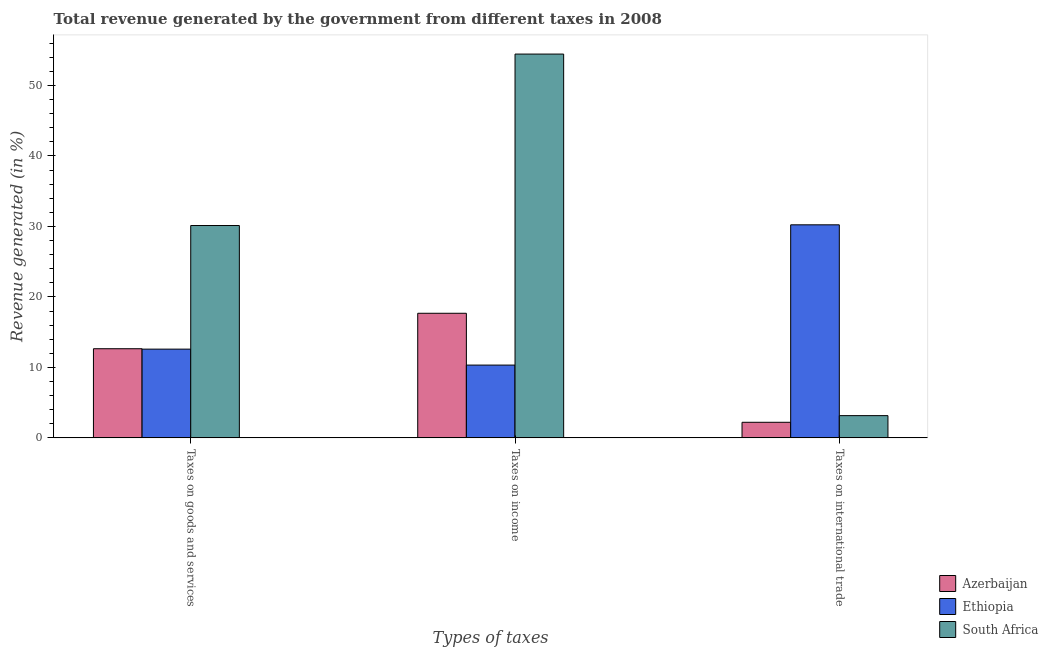How many groups of bars are there?
Offer a very short reply. 3. How many bars are there on the 2nd tick from the left?
Ensure brevity in your answer.  3. What is the label of the 2nd group of bars from the left?
Your response must be concise. Taxes on income. What is the percentage of revenue generated by taxes on income in South Africa?
Provide a short and direct response. 54.45. Across all countries, what is the maximum percentage of revenue generated by tax on international trade?
Your response must be concise. 30.23. Across all countries, what is the minimum percentage of revenue generated by tax on international trade?
Your response must be concise. 2.21. In which country was the percentage of revenue generated by tax on international trade maximum?
Your answer should be very brief. Ethiopia. In which country was the percentage of revenue generated by tax on international trade minimum?
Give a very brief answer. Azerbaijan. What is the total percentage of revenue generated by tax on international trade in the graph?
Give a very brief answer. 35.6. What is the difference between the percentage of revenue generated by taxes on income in South Africa and that in Ethiopia?
Make the answer very short. 44.13. What is the difference between the percentage of revenue generated by taxes on goods and services in Ethiopia and the percentage of revenue generated by tax on international trade in South Africa?
Provide a succinct answer. 9.43. What is the average percentage of revenue generated by taxes on goods and services per country?
Your answer should be compact. 18.46. What is the difference between the percentage of revenue generated by taxes on goods and services and percentage of revenue generated by taxes on income in Ethiopia?
Provide a succinct answer. 2.26. What is the ratio of the percentage of revenue generated by taxes on income in Azerbaijan to that in Ethiopia?
Provide a succinct answer. 1.71. Is the percentage of revenue generated by taxes on income in Azerbaijan less than that in Ethiopia?
Ensure brevity in your answer.  No. What is the difference between the highest and the second highest percentage of revenue generated by tax on international trade?
Your answer should be compact. 27.07. What is the difference between the highest and the lowest percentage of revenue generated by taxes on income?
Provide a short and direct response. 44.13. In how many countries, is the percentage of revenue generated by taxes on income greater than the average percentage of revenue generated by taxes on income taken over all countries?
Provide a short and direct response. 1. What does the 2nd bar from the left in Taxes on international trade represents?
Give a very brief answer. Ethiopia. What does the 2nd bar from the right in Taxes on income represents?
Your response must be concise. Ethiopia. Is it the case that in every country, the sum of the percentage of revenue generated by taxes on goods and services and percentage of revenue generated by taxes on income is greater than the percentage of revenue generated by tax on international trade?
Provide a short and direct response. No. How many bars are there?
Give a very brief answer. 9. Are all the bars in the graph horizontal?
Keep it short and to the point. No. What is the difference between two consecutive major ticks on the Y-axis?
Give a very brief answer. 10. Does the graph contain grids?
Make the answer very short. No. How many legend labels are there?
Your answer should be compact. 3. How are the legend labels stacked?
Provide a succinct answer. Vertical. What is the title of the graph?
Your response must be concise. Total revenue generated by the government from different taxes in 2008. Does "Argentina" appear as one of the legend labels in the graph?
Offer a very short reply. No. What is the label or title of the X-axis?
Keep it short and to the point. Types of taxes. What is the label or title of the Y-axis?
Your response must be concise. Revenue generated (in %). What is the Revenue generated (in %) of Azerbaijan in Taxes on goods and services?
Make the answer very short. 12.65. What is the Revenue generated (in %) in Ethiopia in Taxes on goods and services?
Keep it short and to the point. 12.59. What is the Revenue generated (in %) of South Africa in Taxes on goods and services?
Your answer should be very brief. 30.13. What is the Revenue generated (in %) of Azerbaijan in Taxes on income?
Your answer should be compact. 17.68. What is the Revenue generated (in %) of Ethiopia in Taxes on income?
Make the answer very short. 10.33. What is the Revenue generated (in %) of South Africa in Taxes on income?
Your answer should be compact. 54.45. What is the Revenue generated (in %) in Azerbaijan in Taxes on international trade?
Ensure brevity in your answer.  2.21. What is the Revenue generated (in %) of Ethiopia in Taxes on international trade?
Keep it short and to the point. 30.23. What is the Revenue generated (in %) of South Africa in Taxes on international trade?
Your response must be concise. 3.16. Across all Types of taxes, what is the maximum Revenue generated (in %) in Azerbaijan?
Provide a short and direct response. 17.68. Across all Types of taxes, what is the maximum Revenue generated (in %) of Ethiopia?
Give a very brief answer. 30.23. Across all Types of taxes, what is the maximum Revenue generated (in %) of South Africa?
Ensure brevity in your answer.  54.45. Across all Types of taxes, what is the minimum Revenue generated (in %) in Azerbaijan?
Provide a succinct answer. 2.21. Across all Types of taxes, what is the minimum Revenue generated (in %) of Ethiopia?
Make the answer very short. 10.33. Across all Types of taxes, what is the minimum Revenue generated (in %) of South Africa?
Your answer should be compact. 3.16. What is the total Revenue generated (in %) of Azerbaijan in the graph?
Your response must be concise. 32.54. What is the total Revenue generated (in %) in Ethiopia in the graph?
Provide a succinct answer. 53.14. What is the total Revenue generated (in %) in South Africa in the graph?
Provide a short and direct response. 87.74. What is the difference between the Revenue generated (in %) in Azerbaijan in Taxes on goods and services and that in Taxes on income?
Make the answer very short. -5.03. What is the difference between the Revenue generated (in %) of Ethiopia in Taxes on goods and services and that in Taxes on income?
Offer a terse response. 2.26. What is the difference between the Revenue generated (in %) of South Africa in Taxes on goods and services and that in Taxes on income?
Ensure brevity in your answer.  -24.33. What is the difference between the Revenue generated (in %) in Azerbaijan in Taxes on goods and services and that in Taxes on international trade?
Provide a short and direct response. 10.44. What is the difference between the Revenue generated (in %) of Ethiopia in Taxes on goods and services and that in Taxes on international trade?
Keep it short and to the point. -17.64. What is the difference between the Revenue generated (in %) in South Africa in Taxes on goods and services and that in Taxes on international trade?
Offer a terse response. 26.97. What is the difference between the Revenue generated (in %) in Azerbaijan in Taxes on income and that in Taxes on international trade?
Make the answer very short. 15.47. What is the difference between the Revenue generated (in %) of Ethiopia in Taxes on income and that in Taxes on international trade?
Provide a succinct answer. -19.9. What is the difference between the Revenue generated (in %) in South Africa in Taxes on income and that in Taxes on international trade?
Keep it short and to the point. 51.3. What is the difference between the Revenue generated (in %) of Azerbaijan in Taxes on goods and services and the Revenue generated (in %) of Ethiopia in Taxes on income?
Keep it short and to the point. 2.32. What is the difference between the Revenue generated (in %) in Azerbaijan in Taxes on goods and services and the Revenue generated (in %) in South Africa in Taxes on income?
Ensure brevity in your answer.  -41.81. What is the difference between the Revenue generated (in %) of Ethiopia in Taxes on goods and services and the Revenue generated (in %) of South Africa in Taxes on income?
Offer a very short reply. -41.87. What is the difference between the Revenue generated (in %) in Azerbaijan in Taxes on goods and services and the Revenue generated (in %) in Ethiopia in Taxes on international trade?
Your response must be concise. -17.58. What is the difference between the Revenue generated (in %) in Azerbaijan in Taxes on goods and services and the Revenue generated (in %) in South Africa in Taxes on international trade?
Offer a very short reply. 9.49. What is the difference between the Revenue generated (in %) of Ethiopia in Taxes on goods and services and the Revenue generated (in %) of South Africa in Taxes on international trade?
Provide a succinct answer. 9.43. What is the difference between the Revenue generated (in %) of Azerbaijan in Taxes on income and the Revenue generated (in %) of Ethiopia in Taxes on international trade?
Offer a terse response. -12.55. What is the difference between the Revenue generated (in %) of Azerbaijan in Taxes on income and the Revenue generated (in %) of South Africa in Taxes on international trade?
Make the answer very short. 14.52. What is the difference between the Revenue generated (in %) of Ethiopia in Taxes on income and the Revenue generated (in %) of South Africa in Taxes on international trade?
Your response must be concise. 7.17. What is the average Revenue generated (in %) in Azerbaijan per Types of taxes?
Offer a terse response. 10.85. What is the average Revenue generated (in %) in Ethiopia per Types of taxes?
Ensure brevity in your answer.  17.71. What is the average Revenue generated (in %) of South Africa per Types of taxes?
Offer a terse response. 29.25. What is the difference between the Revenue generated (in %) in Azerbaijan and Revenue generated (in %) in Ethiopia in Taxes on goods and services?
Offer a very short reply. 0.06. What is the difference between the Revenue generated (in %) in Azerbaijan and Revenue generated (in %) in South Africa in Taxes on goods and services?
Provide a short and direct response. -17.48. What is the difference between the Revenue generated (in %) of Ethiopia and Revenue generated (in %) of South Africa in Taxes on goods and services?
Provide a short and direct response. -17.54. What is the difference between the Revenue generated (in %) of Azerbaijan and Revenue generated (in %) of Ethiopia in Taxes on income?
Offer a terse response. 7.35. What is the difference between the Revenue generated (in %) in Azerbaijan and Revenue generated (in %) in South Africa in Taxes on income?
Offer a very short reply. -36.78. What is the difference between the Revenue generated (in %) of Ethiopia and Revenue generated (in %) of South Africa in Taxes on income?
Keep it short and to the point. -44.13. What is the difference between the Revenue generated (in %) in Azerbaijan and Revenue generated (in %) in Ethiopia in Taxes on international trade?
Give a very brief answer. -28.02. What is the difference between the Revenue generated (in %) of Azerbaijan and Revenue generated (in %) of South Africa in Taxes on international trade?
Provide a short and direct response. -0.94. What is the difference between the Revenue generated (in %) in Ethiopia and Revenue generated (in %) in South Africa in Taxes on international trade?
Ensure brevity in your answer.  27.07. What is the ratio of the Revenue generated (in %) of Azerbaijan in Taxes on goods and services to that in Taxes on income?
Ensure brevity in your answer.  0.72. What is the ratio of the Revenue generated (in %) in Ethiopia in Taxes on goods and services to that in Taxes on income?
Make the answer very short. 1.22. What is the ratio of the Revenue generated (in %) in South Africa in Taxes on goods and services to that in Taxes on income?
Make the answer very short. 0.55. What is the ratio of the Revenue generated (in %) in Azerbaijan in Taxes on goods and services to that in Taxes on international trade?
Provide a short and direct response. 5.72. What is the ratio of the Revenue generated (in %) in Ethiopia in Taxes on goods and services to that in Taxes on international trade?
Your answer should be very brief. 0.42. What is the ratio of the Revenue generated (in %) of South Africa in Taxes on goods and services to that in Taxes on international trade?
Provide a succinct answer. 9.55. What is the ratio of the Revenue generated (in %) in Azerbaijan in Taxes on income to that in Taxes on international trade?
Your response must be concise. 7.99. What is the ratio of the Revenue generated (in %) of Ethiopia in Taxes on income to that in Taxes on international trade?
Make the answer very short. 0.34. What is the ratio of the Revenue generated (in %) of South Africa in Taxes on income to that in Taxes on international trade?
Provide a succinct answer. 17.26. What is the difference between the highest and the second highest Revenue generated (in %) of Azerbaijan?
Your answer should be compact. 5.03. What is the difference between the highest and the second highest Revenue generated (in %) of Ethiopia?
Your answer should be compact. 17.64. What is the difference between the highest and the second highest Revenue generated (in %) of South Africa?
Provide a short and direct response. 24.33. What is the difference between the highest and the lowest Revenue generated (in %) of Azerbaijan?
Offer a very short reply. 15.47. What is the difference between the highest and the lowest Revenue generated (in %) in Ethiopia?
Ensure brevity in your answer.  19.9. What is the difference between the highest and the lowest Revenue generated (in %) in South Africa?
Keep it short and to the point. 51.3. 